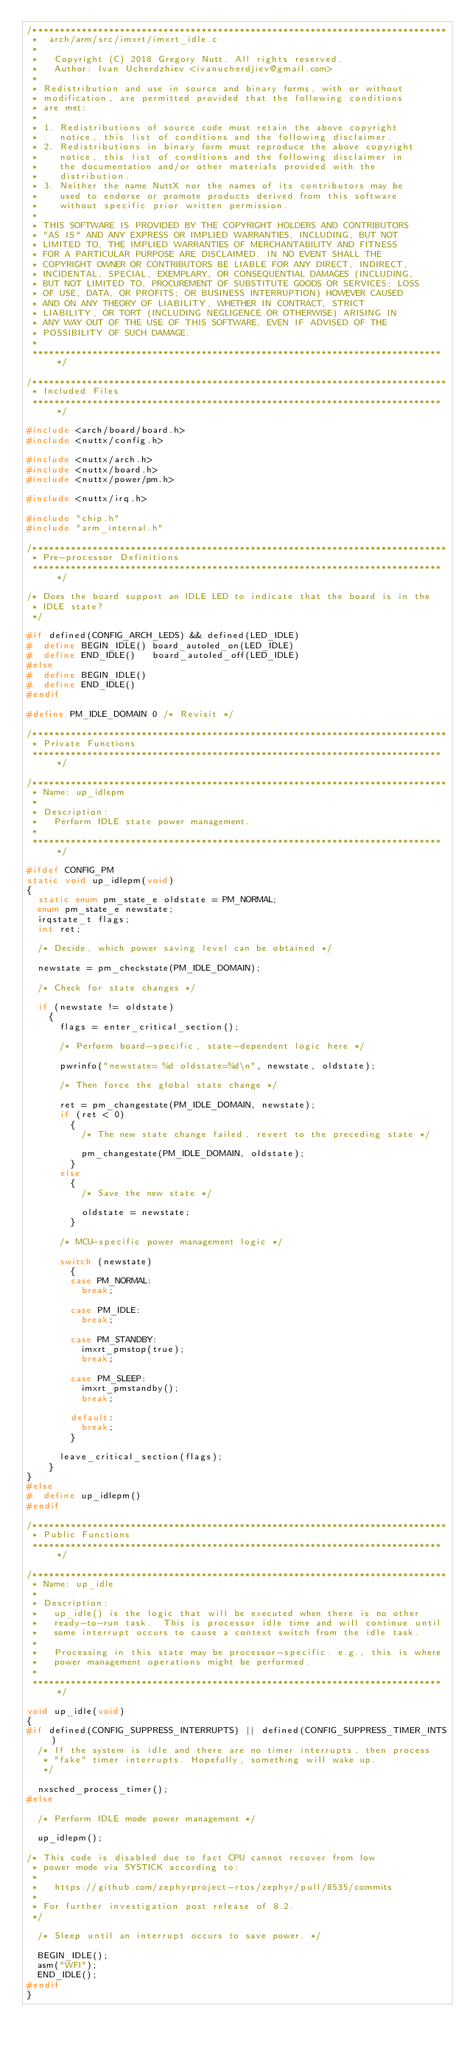Convert code to text. <code><loc_0><loc_0><loc_500><loc_500><_C_>/****************************************************************************
 *  arch/arm/src/imxrt/imxrt_idle.c
 *
 *   Copyright (C) 2018 Gregory Nutt. All rights reserved.
 *   Author: Ivan Ucherdzhiev <ivanucherdjiev@gmail.com>
 *
 * Redistribution and use in source and binary forms, with or without
 * modification, are permitted provided that the following conditions
 * are met:
 *
 * 1. Redistributions of source code must retain the above copyright
 *    notice, this list of conditions and the following disclaimer.
 * 2. Redistributions in binary form must reproduce the above copyright
 *    notice, this list of conditions and the following disclaimer in
 *    the documentation and/or other materials provided with the
 *    distribution.
 * 3. Neither the name NuttX nor the names of its contributors may be
 *    used to endorse or promote products derived from this software
 *    without specific prior written permission.
 *
 * THIS SOFTWARE IS PROVIDED BY THE COPYRIGHT HOLDERS AND CONTRIBUTORS
 * "AS IS" AND ANY EXPRESS OR IMPLIED WARRANTIES, INCLUDING, BUT NOT
 * LIMITED TO, THE IMPLIED WARRANTIES OF MERCHANTABILITY AND FITNESS
 * FOR A PARTICULAR PURPOSE ARE DISCLAIMED. IN NO EVENT SHALL THE
 * COPYRIGHT OWNER OR CONTRIBUTORS BE LIABLE FOR ANY DIRECT, INDIRECT,
 * INCIDENTAL, SPECIAL, EXEMPLARY, OR CONSEQUENTIAL DAMAGES (INCLUDING,
 * BUT NOT LIMITED TO, PROCUREMENT OF SUBSTITUTE GOODS OR SERVICES; LOSS
 * OF USE, DATA, OR PROFITS; OR BUSINESS INTERRUPTION) HOWEVER CAUSED
 * AND ON ANY THEORY OF LIABILITY, WHETHER IN CONTRACT, STRICT
 * LIABILITY, OR TORT (INCLUDING NEGLIGENCE OR OTHERWISE) ARISING IN
 * ANY WAY OUT OF THE USE OF THIS SOFTWARE, EVEN IF ADVISED OF THE
 * POSSIBILITY OF SUCH DAMAGE.
 *
 ****************************************************************************/

/****************************************************************************
 * Included Files
 ****************************************************************************/

#include <arch/board/board.h>
#include <nuttx/config.h>

#include <nuttx/arch.h>
#include <nuttx/board.h>
#include <nuttx/power/pm.h>

#include <nuttx/irq.h>

#include "chip.h"
#include "arm_internal.h"

/****************************************************************************
 * Pre-processor Definitions
 ****************************************************************************/

/* Does the board support an IDLE LED to indicate that the board is in the
 * IDLE state?
 */

#if defined(CONFIG_ARCH_LEDS) && defined(LED_IDLE)
#  define BEGIN_IDLE() board_autoled_on(LED_IDLE)
#  define END_IDLE()   board_autoled_off(LED_IDLE)
#else
#  define BEGIN_IDLE()
#  define END_IDLE()
#endif

#define PM_IDLE_DOMAIN 0 /* Revisit */

/****************************************************************************
 * Private Functions
 ****************************************************************************/

/****************************************************************************
 * Name: up_idlepm
 *
 * Description:
 *   Perform IDLE state power management.
 *
 ****************************************************************************/

#ifdef CONFIG_PM
static void up_idlepm(void)
{
  static enum pm_state_e oldstate = PM_NORMAL;
  enum pm_state_e newstate;
  irqstate_t flags;
  int ret;

  /* Decide, which power saving level can be obtained */

  newstate = pm_checkstate(PM_IDLE_DOMAIN);

  /* Check for state changes */

  if (newstate != oldstate)
    {
      flags = enter_critical_section();

      /* Perform board-specific, state-dependent logic here */

      pwrinfo("newstate= %d oldstate=%d\n", newstate, oldstate);

      /* Then force the global state change */

      ret = pm_changestate(PM_IDLE_DOMAIN, newstate);
      if (ret < 0)
        {
          /* The new state change failed, revert to the preceding state */

          pm_changestate(PM_IDLE_DOMAIN, oldstate);
        }
      else
        {
          /* Save the new state */

          oldstate = newstate;
        }

      /* MCU-specific power management logic */

      switch (newstate)
        {
        case PM_NORMAL:
          break;

        case PM_IDLE:
          break;

        case PM_STANDBY:
          imxrt_pmstop(true);
          break;

        case PM_SLEEP:
          imxrt_pmstandby();
          break;

        default:
          break;
        }

      leave_critical_section(flags);
    }
}
#else
#  define up_idlepm()
#endif

/****************************************************************************
 * Public Functions
 ****************************************************************************/

/****************************************************************************
 * Name: up_idle
 *
 * Description:
 *   up_idle() is the logic that will be executed when there is no other
 *   ready-to-run task.  This is processor idle time and will continue until
 *   some interrupt occurs to cause a context switch from the idle task.
 *
 *   Processing in this state may be processor-specific. e.g., this is where
 *   power management operations might be performed.
 *
 ****************************************************************************/

void up_idle(void)
{
#if defined(CONFIG_SUPPRESS_INTERRUPTS) || defined(CONFIG_SUPPRESS_TIMER_INTS)
  /* If the system is idle and there are no timer interrupts, then process
   * "fake" timer interrupts. Hopefully, something will wake up.
   */

  nxsched_process_timer();
#else

  /* Perform IDLE mode power management */

  up_idlepm();

/* This code is disabled due to fact CPU cannot recover from low
 * power mode via SYSTICK according to:
 *
 *   https://github.com/zephyrproject-rtos/zephyr/pull/8535/commits
 *
 * For further investigation post release of 8.2.
 */

  /* Sleep until an interrupt occurs to save power. */

  BEGIN_IDLE();
  asm("WFI");
  END_IDLE();
#endif
}
</code> 